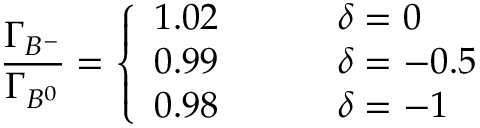<formula> <loc_0><loc_0><loc_500><loc_500>{ \frac { \Gamma _ { B ^ { - } } } { \Gamma _ { B ^ { 0 } } } } = \left \{ \begin{array} { l l } { 1 . 0 2 \, } & { \delta = 0 } \\ { 0 . 9 9 \, } & { \delta = - 0 . 5 } \\ { 0 . 9 8 } & { \delta = - 1 } \end{array}</formula> 